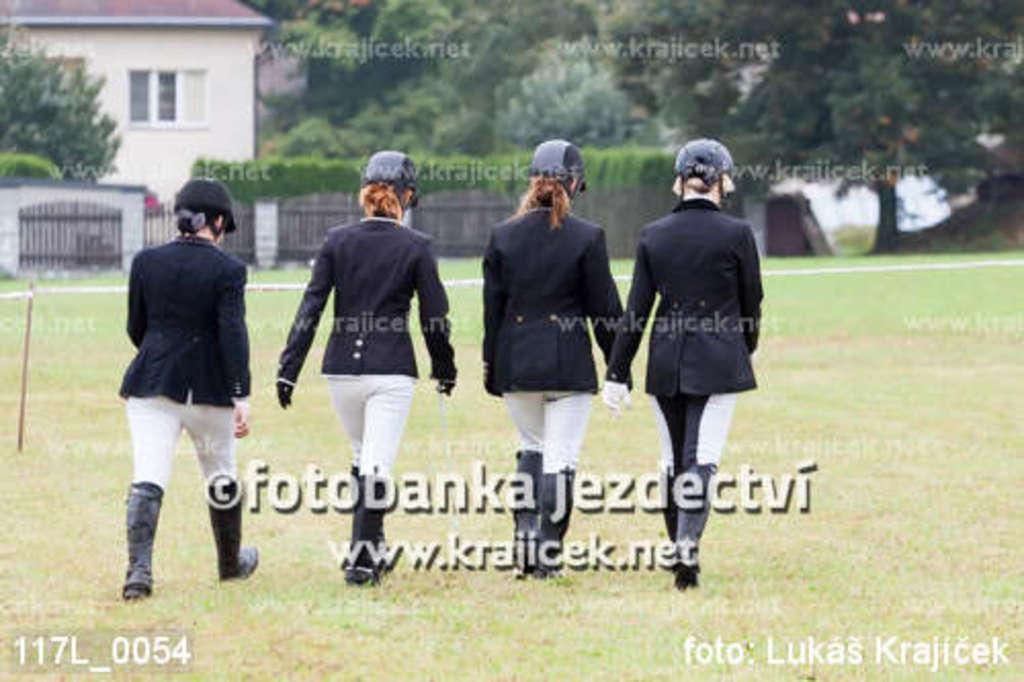How many women are walking in the image? There are four women walking in the image. What can be seen in the background of the image? There is a gate, trees, bushes, a house with a window, and grass visible in the image. What type of fan can be seen in the image? There is no fan present in the image. Can you hear the song being sung by the women in the image? The image is a still photograph, so there is no sound or singing present. 